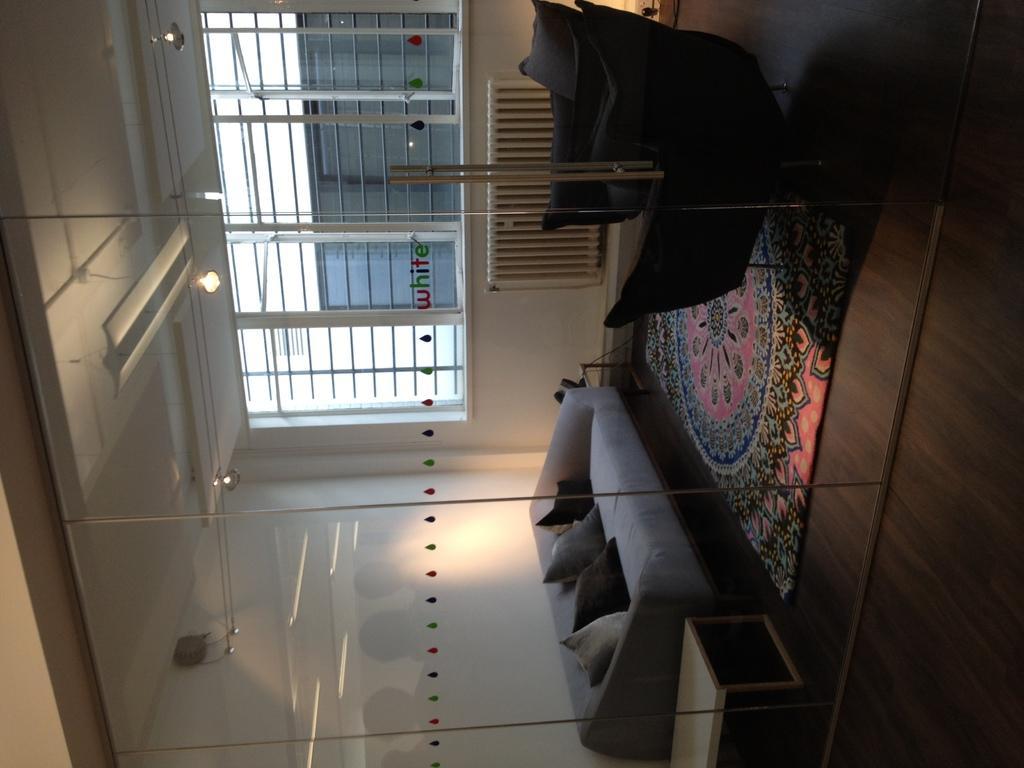Could you give a brief overview of what you see in this image? This image is in left direction. On the right side there is a couch, chairs and a mat on the floor. On the couch there are few pillows. On the left side there are few lights. In the background there is a window to the wall through the window we can see the outside view. In the outside there is another window to a wall. At the bottom there is a glass. It seems like a cabin. 